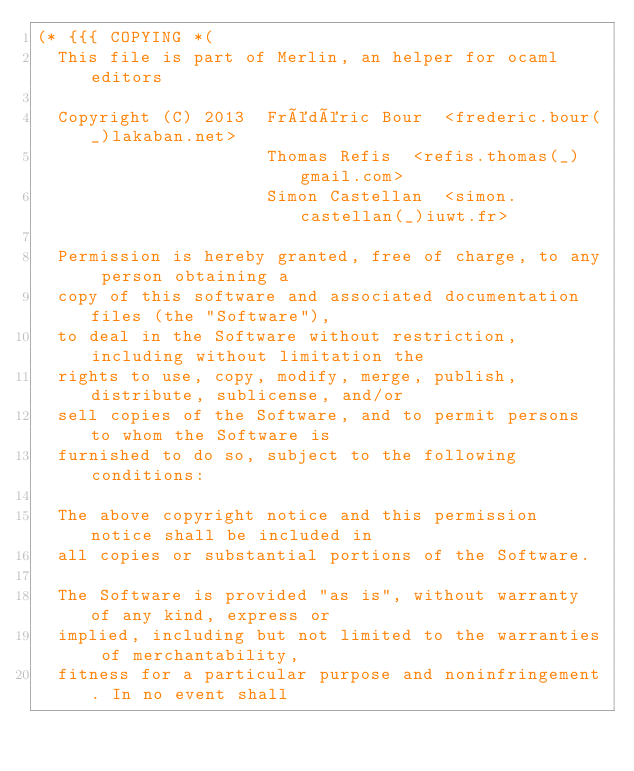Convert code to text. <code><loc_0><loc_0><loc_500><loc_500><_OCaml_>(* {{{ COPYING *(
  This file is part of Merlin, an helper for ocaml editors

  Copyright (C) 2013  Frédéric Bour  <frederic.bour(_)lakaban.net>
                      Thomas Refis  <refis.thomas(_)gmail.com>
                      Simon Castellan  <simon.castellan(_)iuwt.fr>

  Permission is hereby granted, free of charge, to any person obtaining a
  copy of this software and associated documentation files (the "Software"),
  to deal in the Software without restriction, including without limitation the
  rights to use, copy, modify, merge, publish, distribute, sublicense, and/or
  sell copies of the Software, and to permit persons to whom the Software is
  furnished to do so, subject to the following conditions:

  The above copyright notice and this permission notice shall be included in
  all copies or substantial portions of the Software.

  The Software is provided "as is", without warranty of any kind, express or
  implied, including but not limited to the warranties of merchantability,
  fitness for a particular purpose and noninfringement. In no event shall</code> 